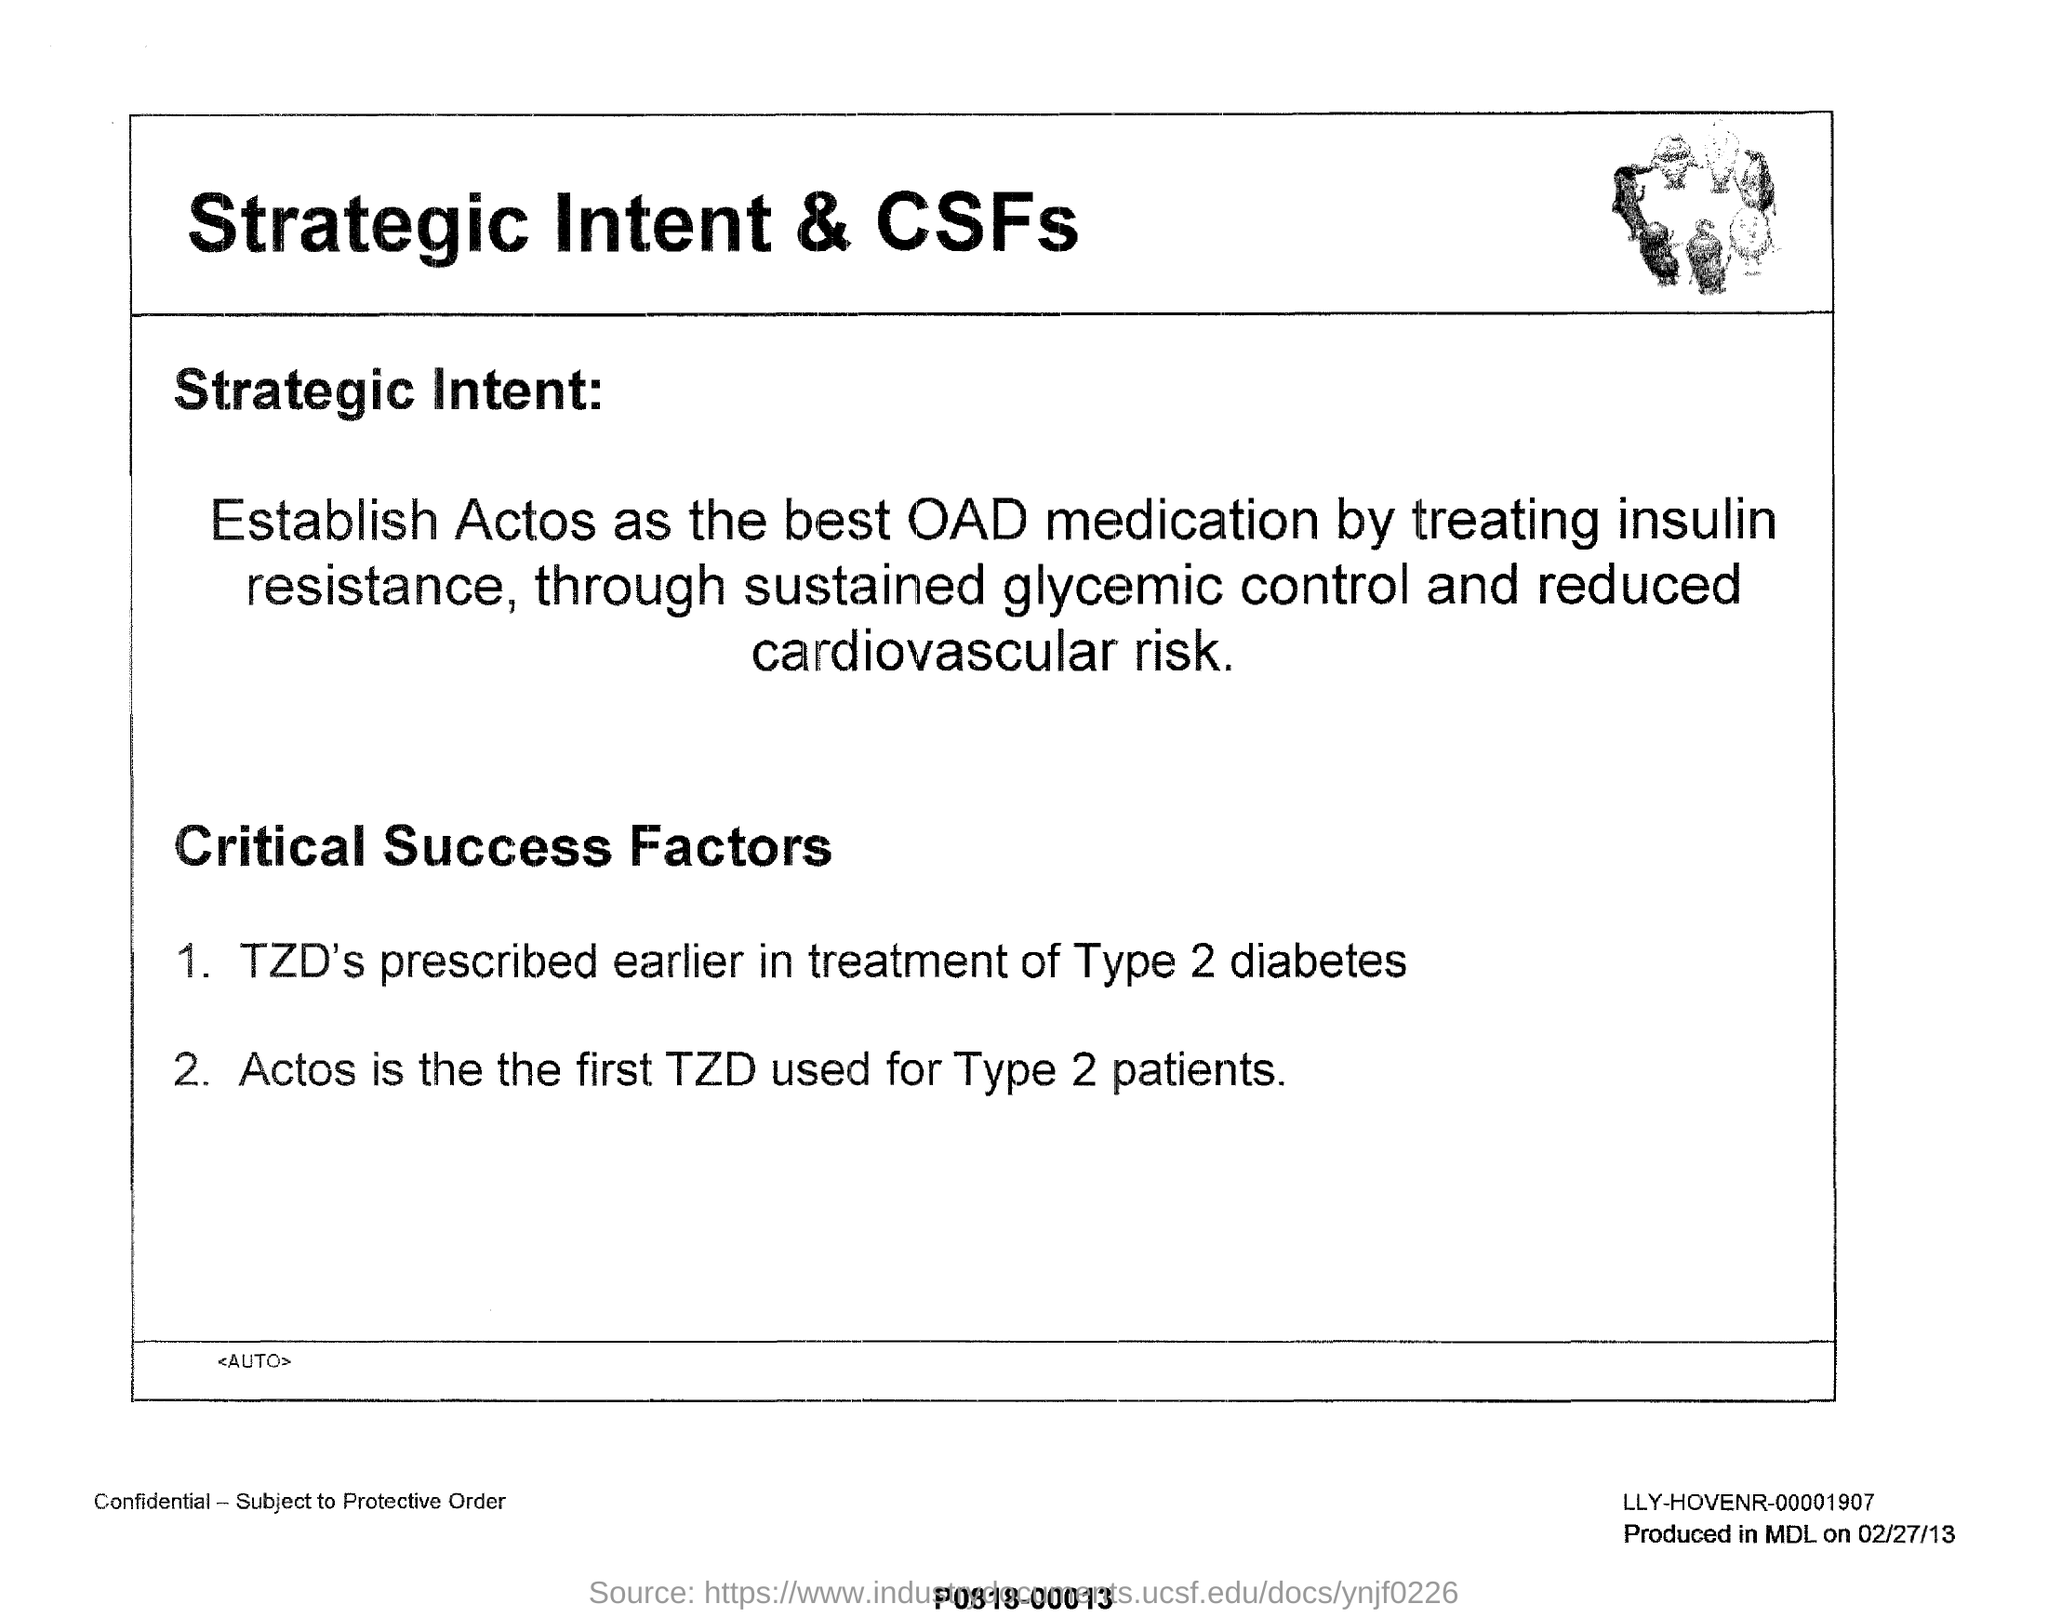What is the first tzd used for type 2 patients ?
Your answer should be very brief. ACTOS. For which type of diabetes the TZD's prescribed earlier in treatment?
Your answer should be very brief. Type 2 diabetes. What has to be establish as the the best oad medication by treating insulin resistance ?
Make the answer very short. ACTOS. 